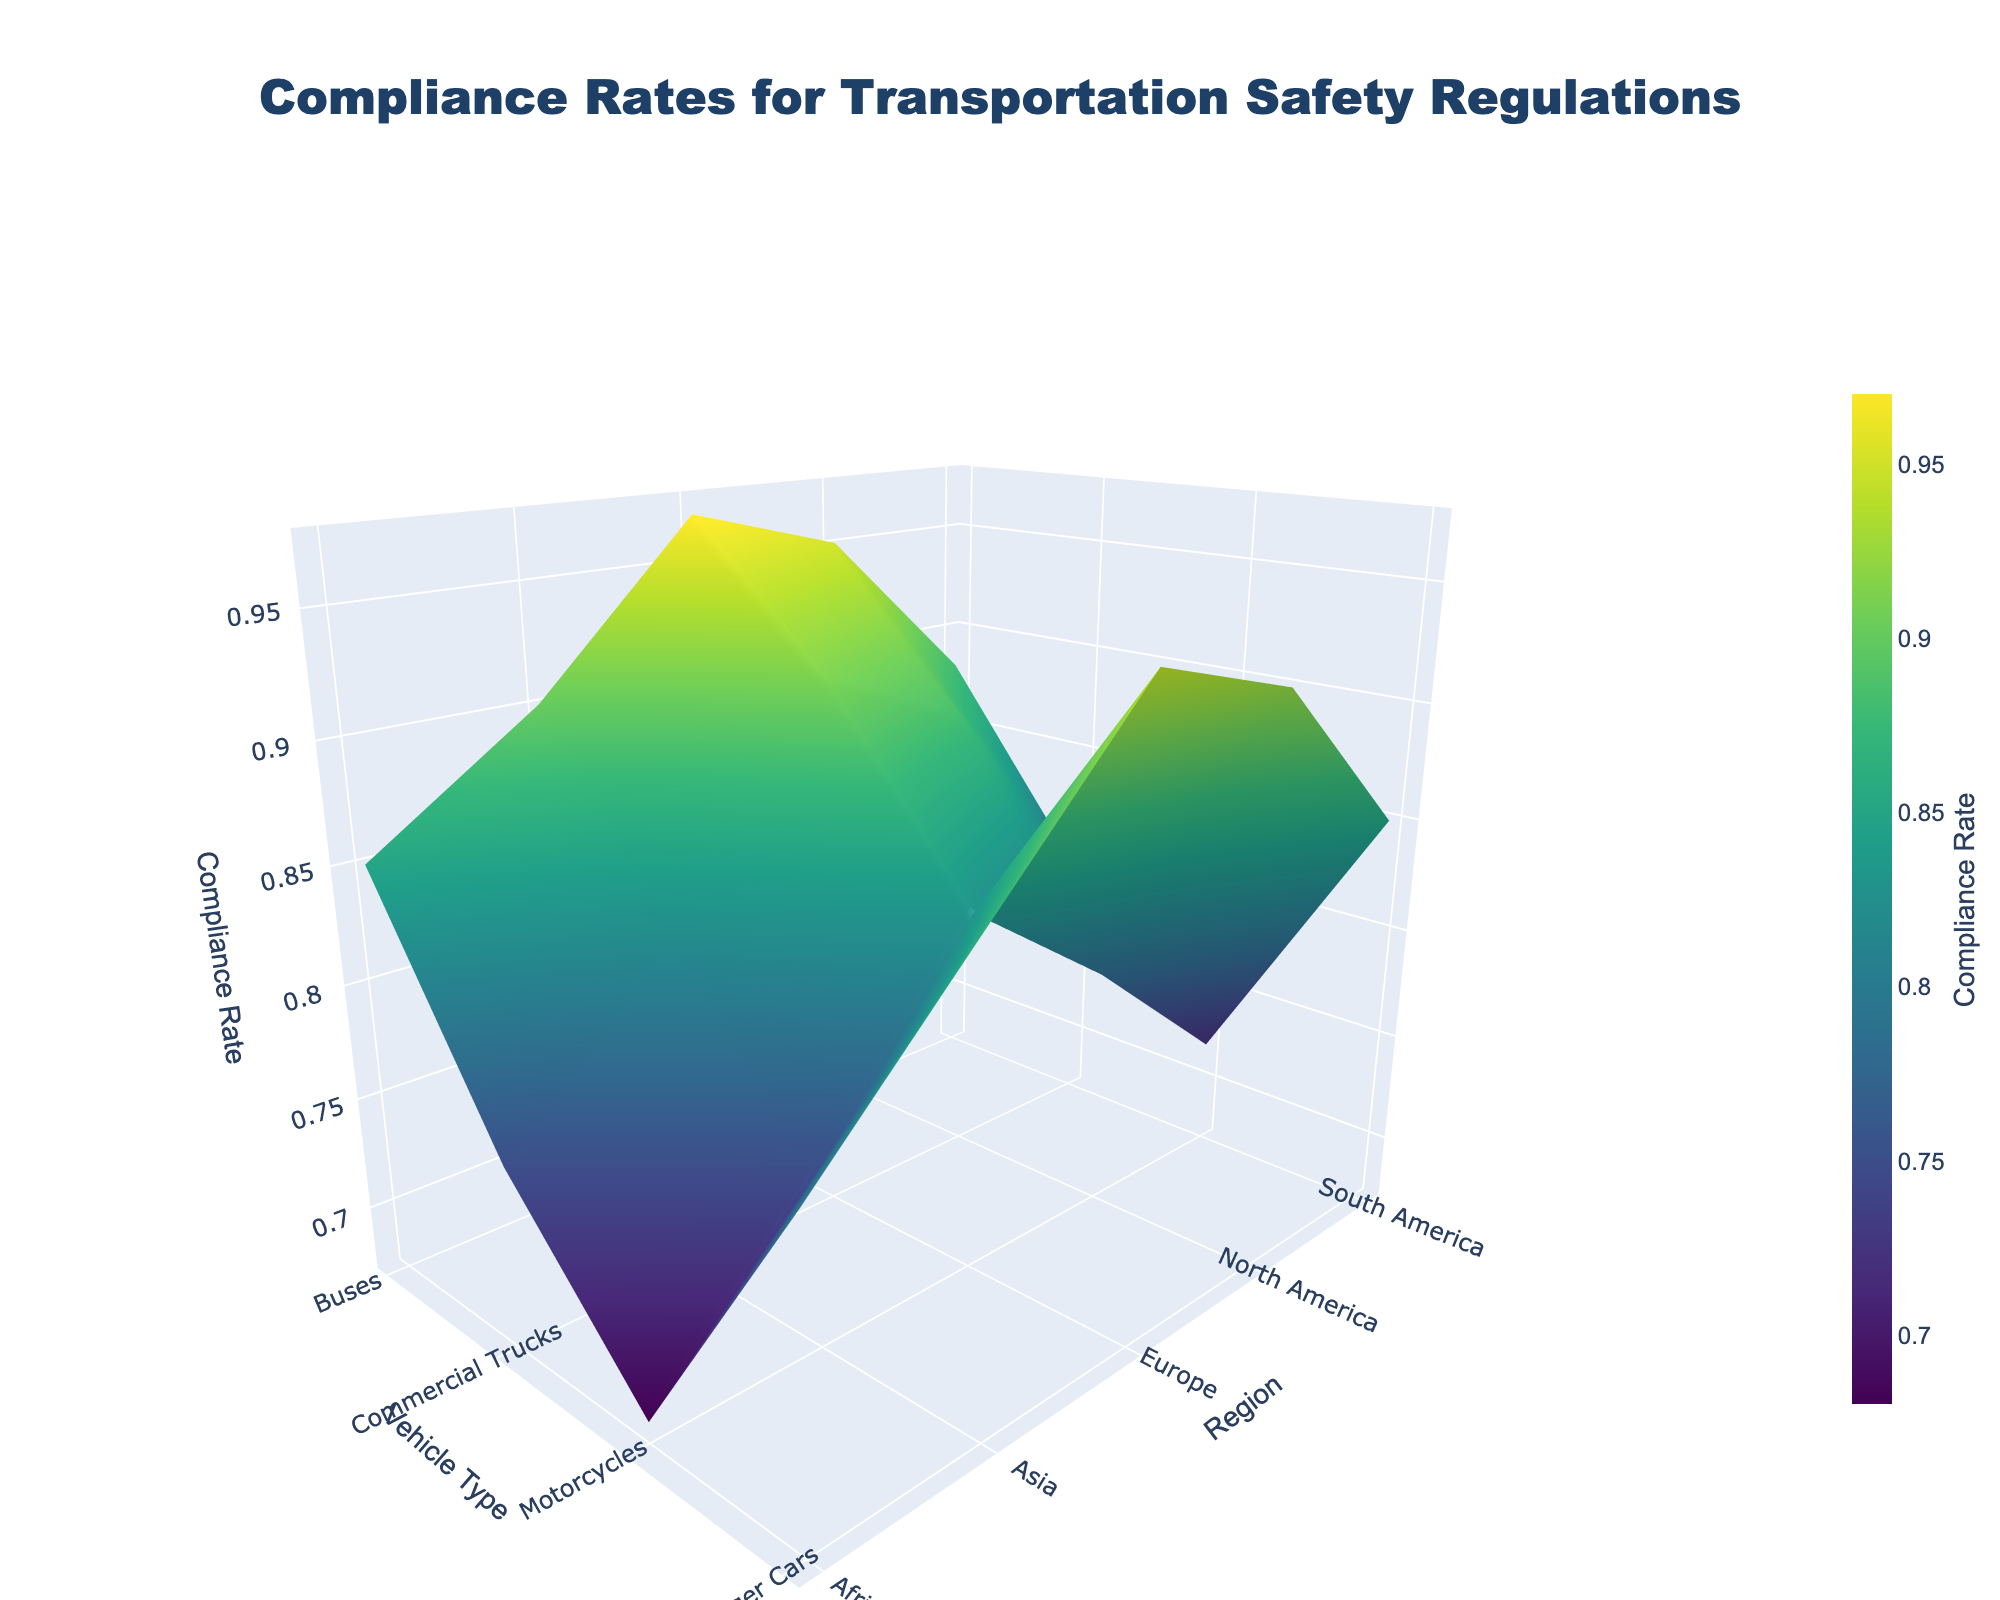What's the title of the plot? The title is usually located at the top of the plot and provides a brief description of the data being visualized. Here, it reads "Compliance Rates for Transportation Safety Regulations".
Answer: Compliance Rates for Transportation Safety Regulations What are the labels on the axes? The 3D plot has three axes: the x-axis, y-axis, and z-axis. The x-axis is labeled "Vehicle Type", the y-axis is labeled "Region", and the z-axis is labeled "Compliance Rate".
Answer: Vehicle Type, Region, Compliance Rate Which region has the highest compliance rate for motorcycles? Identify the point corresponding to "Motorcycles" on the Vehicle Type (x-axis) and find the maximum value on the z-axis for the different regions. The highest compliance rate for motorcycles appears in Europe.
Answer: Europe Which vehicle type generally shows the lowest compliance rate across regions? Review the surface plot across all regions and identify the vehicle type with the consistently lowest values on the z-axis. "Motorcycles" generally show the lowest compliance rates across regions.
Answer: Motorcycles Compare the compliance rate of buses in North America and Europe. Which one is higher? Locate the compliance rates for Buses on the z-axis for both North America and Europe. Europe has a higher compliance rate for buses compared to North America.
Answer: Europe What is the average compliance rate for commercial trucks across all regions? Sum the compliance rates for commercial trucks across all regions and divide by the number of regions (0.88 + 0.91 + 0.82 + 0.79 + 0.75) / 5. Calculate the average: (0.88 + 0.91 + 0.82 + 0.79 + 0.75) / 5 = 4.15 / 5 = 0.83.
Answer: 0.83 Which region has the most consistent compliance rates across all vehicle types? Consistency can be judged by the variation in compliance rates across vehicle types in a region. North America has a slight variation from 0.78 to 0.95, Europe from 0.83 to 0.97, Asia from 0.75 to 0.90, South America from 0.72 to 0.88, and Africa from lower values ranging from 0.68 to 0.85. Europe has the most consistent compliance rates.
Answer: Europe For Asia, what is the difference in compliance rates between Passenger Cars and Motorcycles? Identify the compliance rates for Passenger Cars and Motorcycles in Asia: 0.87 and 0.75. Subtract the compliance rate of Motorcycles from that of Passenger Cars: 0.87 - 0.75 = 0.12.
Answer: 0.12 